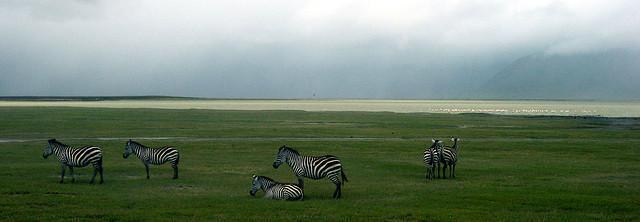What is on the grass?
Choose the right answer from the provided options to respond to the question.
Options: Zebras, apples, cows, elephants. Zebras. 